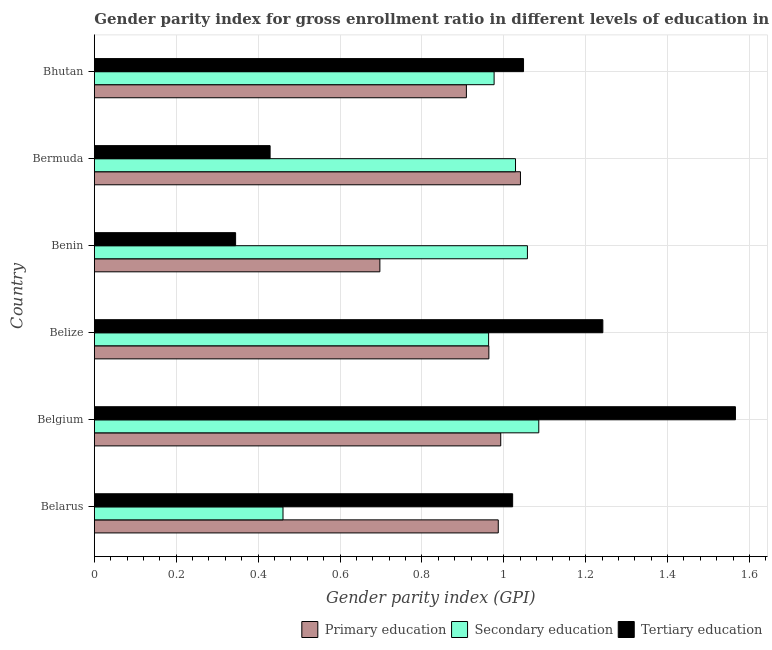How many different coloured bars are there?
Give a very brief answer. 3. Are the number of bars per tick equal to the number of legend labels?
Keep it short and to the point. Yes. How many bars are there on the 5th tick from the top?
Offer a terse response. 3. How many bars are there on the 1st tick from the bottom?
Your response must be concise. 3. What is the label of the 4th group of bars from the top?
Make the answer very short. Belize. What is the gender parity index in secondary education in Bermuda?
Offer a terse response. 1.03. Across all countries, what is the maximum gender parity index in primary education?
Your response must be concise. 1.04. Across all countries, what is the minimum gender parity index in secondary education?
Make the answer very short. 0.46. In which country was the gender parity index in primary education maximum?
Provide a short and direct response. Bermuda. In which country was the gender parity index in tertiary education minimum?
Your response must be concise. Benin. What is the total gender parity index in tertiary education in the graph?
Offer a very short reply. 5.65. What is the difference between the gender parity index in tertiary education in Belize and that in Bhutan?
Your response must be concise. 0.19. What is the difference between the gender parity index in secondary education in Bermuda and the gender parity index in tertiary education in Benin?
Offer a terse response. 0.68. What is the average gender parity index in primary education per country?
Give a very brief answer. 0.93. What is the difference between the gender parity index in tertiary education and gender parity index in secondary education in Belgium?
Your answer should be compact. 0.48. In how many countries, is the gender parity index in tertiary education greater than 1.56 ?
Provide a succinct answer. 1. What is the ratio of the gender parity index in primary education in Bermuda to that in Bhutan?
Keep it short and to the point. 1.15. Is the gender parity index in tertiary education in Belize less than that in Bhutan?
Provide a short and direct response. No. Is the difference between the gender parity index in secondary education in Belarus and Bhutan greater than the difference between the gender parity index in tertiary education in Belarus and Bhutan?
Your answer should be compact. No. What is the difference between the highest and the second highest gender parity index in tertiary education?
Ensure brevity in your answer.  0.32. What is the difference between the highest and the lowest gender parity index in primary education?
Your answer should be very brief. 0.34. What does the 1st bar from the top in Bhutan represents?
Your answer should be compact. Tertiary education. What does the 2nd bar from the bottom in Belarus represents?
Give a very brief answer. Secondary education. Is it the case that in every country, the sum of the gender parity index in primary education and gender parity index in secondary education is greater than the gender parity index in tertiary education?
Provide a succinct answer. Yes. What is the difference between two consecutive major ticks on the X-axis?
Provide a short and direct response. 0.2. Does the graph contain any zero values?
Make the answer very short. No. Does the graph contain grids?
Give a very brief answer. Yes. How are the legend labels stacked?
Your response must be concise. Horizontal. What is the title of the graph?
Your answer should be compact. Gender parity index for gross enrollment ratio in different levels of education in 2002. What is the label or title of the X-axis?
Offer a terse response. Gender parity index (GPI). What is the Gender parity index (GPI) of Primary education in Belarus?
Provide a succinct answer. 0.99. What is the Gender parity index (GPI) of Secondary education in Belarus?
Offer a very short reply. 0.46. What is the Gender parity index (GPI) in Tertiary education in Belarus?
Provide a short and direct response. 1.02. What is the Gender parity index (GPI) in Primary education in Belgium?
Your response must be concise. 0.99. What is the Gender parity index (GPI) of Secondary education in Belgium?
Ensure brevity in your answer.  1.09. What is the Gender parity index (GPI) in Tertiary education in Belgium?
Make the answer very short. 1.57. What is the Gender parity index (GPI) in Primary education in Belize?
Offer a terse response. 0.96. What is the Gender parity index (GPI) of Secondary education in Belize?
Offer a very short reply. 0.96. What is the Gender parity index (GPI) of Tertiary education in Belize?
Keep it short and to the point. 1.24. What is the Gender parity index (GPI) in Primary education in Benin?
Provide a short and direct response. 0.7. What is the Gender parity index (GPI) of Secondary education in Benin?
Offer a terse response. 1.06. What is the Gender parity index (GPI) in Tertiary education in Benin?
Give a very brief answer. 0.35. What is the Gender parity index (GPI) in Primary education in Bermuda?
Provide a succinct answer. 1.04. What is the Gender parity index (GPI) of Secondary education in Bermuda?
Offer a very short reply. 1.03. What is the Gender parity index (GPI) of Tertiary education in Bermuda?
Provide a succinct answer. 0.43. What is the Gender parity index (GPI) of Primary education in Bhutan?
Your response must be concise. 0.91. What is the Gender parity index (GPI) in Secondary education in Bhutan?
Ensure brevity in your answer.  0.98. What is the Gender parity index (GPI) in Tertiary education in Bhutan?
Your answer should be very brief. 1.05. Across all countries, what is the maximum Gender parity index (GPI) of Primary education?
Your answer should be very brief. 1.04. Across all countries, what is the maximum Gender parity index (GPI) of Secondary education?
Provide a succinct answer. 1.09. Across all countries, what is the maximum Gender parity index (GPI) in Tertiary education?
Offer a very short reply. 1.57. Across all countries, what is the minimum Gender parity index (GPI) in Primary education?
Your response must be concise. 0.7. Across all countries, what is the minimum Gender parity index (GPI) in Secondary education?
Provide a succinct answer. 0.46. Across all countries, what is the minimum Gender parity index (GPI) of Tertiary education?
Offer a terse response. 0.35. What is the total Gender parity index (GPI) of Primary education in the graph?
Provide a short and direct response. 5.59. What is the total Gender parity index (GPI) of Secondary education in the graph?
Offer a very short reply. 5.57. What is the total Gender parity index (GPI) of Tertiary education in the graph?
Offer a very short reply. 5.65. What is the difference between the Gender parity index (GPI) of Primary education in Belarus and that in Belgium?
Give a very brief answer. -0.01. What is the difference between the Gender parity index (GPI) of Secondary education in Belarus and that in Belgium?
Your answer should be compact. -0.62. What is the difference between the Gender parity index (GPI) in Tertiary education in Belarus and that in Belgium?
Your answer should be very brief. -0.54. What is the difference between the Gender parity index (GPI) in Primary education in Belarus and that in Belize?
Provide a succinct answer. 0.02. What is the difference between the Gender parity index (GPI) in Secondary education in Belarus and that in Belize?
Your answer should be very brief. -0.5. What is the difference between the Gender parity index (GPI) of Tertiary education in Belarus and that in Belize?
Provide a succinct answer. -0.22. What is the difference between the Gender parity index (GPI) in Primary education in Belarus and that in Benin?
Your answer should be compact. 0.29. What is the difference between the Gender parity index (GPI) of Secondary education in Belarus and that in Benin?
Offer a very short reply. -0.6. What is the difference between the Gender parity index (GPI) of Tertiary education in Belarus and that in Benin?
Your response must be concise. 0.68. What is the difference between the Gender parity index (GPI) in Primary education in Belarus and that in Bermuda?
Ensure brevity in your answer.  -0.05. What is the difference between the Gender parity index (GPI) of Secondary education in Belarus and that in Bermuda?
Your answer should be compact. -0.57. What is the difference between the Gender parity index (GPI) in Tertiary education in Belarus and that in Bermuda?
Offer a terse response. 0.59. What is the difference between the Gender parity index (GPI) in Primary education in Belarus and that in Bhutan?
Keep it short and to the point. 0.08. What is the difference between the Gender parity index (GPI) of Secondary education in Belarus and that in Bhutan?
Your answer should be compact. -0.52. What is the difference between the Gender parity index (GPI) in Tertiary education in Belarus and that in Bhutan?
Provide a short and direct response. -0.03. What is the difference between the Gender parity index (GPI) in Primary education in Belgium and that in Belize?
Give a very brief answer. 0.03. What is the difference between the Gender parity index (GPI) in Secondary education in Belgium and that in Belize?
Make the answer very short. 0.12. What is the difference between the Gender parity index (GPI) in Tertiary education in Belgium and that in Belize?
Your response must be concise. 0.32. What is the difference between the Gender parity index (GPI) in Primary education in Belgium and that in Benin?
Keep it short and to the point. 0.3. What is the difference between the Gender parity index (GPI) in Secondary education in Belgium and that in Benin?
Give a very brief answer. 0.03. What is the difference between the Gender parity index (GPI) of Tertiary education in Belgium and that in Benin?
Make the answer very short. 1.22. What is the difference between the Gender parity index (GPI) in Primary education in Belgium and that in Bermuda?
Your answer should be compact. -0.05. What is the difference between the Gender parity index (GPI) of Secondary education in Belgium and that in Bermuda?
Offer a very short reply. 0.06. What is the difference between the Gender parity index (GPI) of Tertiary education in Belgium and that in Bermuda?
Provide a short and direct response. 1.14. What is the difference between the Gender parity index (GPI) of Primary education in Belgium and that in Bhutan?
Provide a succinct answer. 0.08. What is the difference between the Gender parity index (GPI) of Secondary education in Belgium and that in Bhutan?
Your answer should be very brief. 0.11. What is the difference between the Gender parity index (GPI) in Tertiary education in Belgium and that in Bhutan?
Your response must be concise. 0.52. What is the difference between the Gender parity index (GPI) in Primary education in Belize and that in Benin?
Offer a very short reply. 0.27. What is the difference between the Gender parity index (GPI) of Secondary education in Belize and that in Benin?
Your response must be concise. -0.09. What is the difference between the Gender parity index (GPI) in Tertiary education in Belize and that in Benin?
Ensure brevity in your answer.  0.9. What is the difference between the Gender parity index (GPI) in Primary education in Belize and that in Bermuda?
Offer a terse response. -0.08. What is the difference between the Gender parity index (GPI) in Secondary education in Belize and that in Bermuda?
Keep it short and to the point. -0.07. What is the difference between the Gender parity index (GPI) of Tertiary education in Belize and that in Bermuda?
Provide a succinct answer. 0.81. What is the difference between the Gender parity index (GPI) of Primary education in Belize and that in Bhutan?
Provide a succinct answer. 0.05. What is the difference between the Gender parity index (GPI) of Secondary education in Belize and that in Bhutan?
Give a very brief answer. -0.01. What is the difference between the Gender parity index (GPI) of Tertiary education in Belize and that in Bhutan?
Your answer should be compact. 0.19. What is the difference between the Gender parity index (GPI) in Primary education in Benin and that in Bermuda?
Make the answer very short. -0.34. What is the difference between the Gender parity index (GPI) in Secondary education in Benin and that in Bermuda?
Provide a short and direct response. 0.03. What is the difference between the Gender parity index (GPI) in Tertiary education in Benin and that in Bermuda?
Provide a succinct answer. -0.08. What is the difference between the Gender parity index (GPI) in Primary education in Benin and that in Bhutan?
Offer a terse response. -0.21. What is the difference between the Gender parity index (GPI) of Secondary education in Benin and that in Bhutan?
Give a very brief answer. 0.08. What is the difference between the Gender parity index (GPI) of Tertiary education in Benin and that in Bhutan?
Your answer should be very brief. -0.7. What is the difference between the Gender parity index (GPI) in Primary education in Bermuda and that in Bhutan?
Ensure brevity in your answer.  0.13. What is the difference between the Gender parity index (GPI) in Secondary education in Bermuda and that in Bhutan?
Provide a succinct answer. 0.05. What is the difference between the Gender parity index (GPI) in Tertiary education in Bermuda and that in Bhutan?
Provide a succinct answer. -0.62. What is the difference between the Gender parity index (GPI) of Primary education in Belarus and the Gender parity index (GPI) of Secondary education in Belgium?
Offer a terse response. -0.1. What is the difference between the Gender parity index (GPI) in Primary education in Belarus and the Gender parity index (GPI) in Tertiary education in Belgium?
Provide a succinct answer. -0.58. What is the difference between the Gender parity index (GPI) in Secondary education in Belarus and the Gender parity index (GPI) in Tertiary education in Belgium?
Your response must be concise. -1.1. What is the difference between the Gender parity index (GPI) in Primary education in Belarus and the Gender parity index (GPI) in Secondary education in Belize?
Offer a very short reply. 0.02. What is the difference between the Gender parity index (GPI) in Primary education in Belarus and the Gender parity index (GPI) in Tertiary education in Belize?
Provide a short and direct response. -0.26. What is the difference between the Gender parity index (GPI) in Secondary education in Belarus and the Gender parity index (GPI) in Tertiary education in Belize?
Your response must be concise. -0.78. What is the difference between the Gender parity index (GPI) of Primary education in Belarus and the Gender parity index (GPI) of Secondary education in Benin?
Your answer should be compact. -0.07. What is the difference between the Gender parity index (GPI) in Primary education in Belarus and the Gender parity index (GPI) in Tertiary education in Benin?
Offer a very short reply. 0.64. What is the difference between the Gender parity index (GPI) of Secondary education in Belarus and the Gender parity index (GPI) of Tertiary education in Benin?
Provide a succinct answer. 0.12. What is the difference between the Gender parity index (GPI) of Primary education in Belarus and the Gender parity index (GPI) of Secondary education in Bermuda?
Your answer should be very brief. -0.04. What is the difference between the Gender parity index (GPI) in Primary education in Belarus and the Gender parity index (GPI) in Tertiary education in Bermuda?
Keep it short and to the point. 0.56. What is the difference between the Gender parity index (GPI) in Secondary education in Belarus and the Gender parity index (GPI) in Tertiary education in Bermuda?
Your response must be concise. 0.03. What is the difference between the Gender parity index (GPI) in Primary education in Belarus and the Gender parity index (GPI) in Secondary education in Bhutan?
Keep it short and to the point. 0.01. What is the difference between the Gender parity index (GPI) of Primary education in Belarus and the Gender parity index (GPI) of Tertiary education in Bhutan?
Give a very brief answer. -0.06. What is the difference between the Gender parity index (GPI) in Secondary education in Belarus and the Gender parity index (GPI) in Tertiary education in Bhutan?
Give a very brief answer. -0.59. What is the difference between the Gender parity index (GPI) in Primary education in Belgium and the Gender parity index (GPI) in Secondary education in Belize?
Ensure brevity in your answer.  0.03. What is the difference between the Gender parity index (GPI) of Primary education in Belgium and the Gender parity index (GPI) of Tertiary education in Belize?
Ensure brevity in your answer.  -0.25. What is the difference between the Gender parity index (GPI) in Secondary education in Belgium and the Gender parity index (GPI) in Tertiary education in Belize?
Provide a short and direct response. -0.16. What is the difference between the Gender parity index (GPI) in Primary education in Belgium and the Gender parity index (GPI) in Secondary education in Benin?
Offer a terse response. -0.07. What is the difference between the Gender parity index (GPI) of Primary education in Belgium and the Gender parity index (GPI) of Tertiary education in Benin?
Give a very brief answer. 0.65. What is the difference between the Gender parity index (GPI) in Secondary education in Belgium and the Gender parity index (GPI) in Tertiary education in Benin?
Give a very brief answer. 0.74. What is the difference between the Gender parity index (GPI) in Primary education in Belgium and the Gender parity index (GPI) in Secondary education in Bermuda?
Provide a short and direct response. -0.04. What is the difference between the Gender parity index (GPI) of Primary education in Belgium and the Gender parity index (GPI) of Tertiary education in Bermuda?
Ensure brevity in your answer.  0.56. What is the difference between the Gender parity index (GPI) in Secondary education in Belgium and the Gender parity index (GPI) in Tertiary education in Bermuda?
Make the answer very short. 0.66. What is the difference between the Gender parity index (GPI) of Primary education in Belgium and the Gender parity index (GPI) of Secondary education in Bhutan?
Offer a very short reply. 0.02. What is the difference between the Gender parity index (GPI) of Primary education in Belgium and the Gender parity index (GPI) of Tertiary education in Bhutan?
Give a very brief answer. -0.06. What is the difference between the Gender parity index (GPI) in Secondary education in Belgium and the Gender parity index (GPI) in Tertiary education in Bhutan?
Offer a very short reply. 0.04. What is the difference between the Gender parity index (GPI) in Primary education in Belize and the Gender parity index (GPI) in Secondary education in Benin?
Your answer should be compact. -0.09. What is the difference between the Gender parity index (GPI) of Primary education in Belize and the Gender parity index (GPI) of Tertiary education in Benin?
Give a very brief answer. 0.62. What is the difference between the Gender parity index (GPI) of Secondary education in Belize and the Gender parity index (GPI) of Tertiary education in Benin?
Your answer should be very brief. 0.62. What is the difference between the Gender parity index (GPI) in Primary education in Belize and the Gender parity index (GPI) in Secondary education in Bermuda?
Offer a terse response. -0.07. What is the difference between the Gender parity index (GPI) in Primary education in Belize and the Gender parity index (GPI) in Tertiary education in Bermuda?
Keep it short and to the point. 0.53. What is the difference between the Gender parity index (GPI) in Secondary education in Belize and the Gender parity index (GPI) in Tertiary education in Bermuda?
Offer a very short reply. 0.53. What is the difference between the Gender parity index (GPI) of Primary education in Belize and the Gender parity index (GPI) of Secondary education in Bhutan?
Your answer should be compact. -0.01. What is the difference between the Gender parity index (GPI) in Primary education in Belize and the Gender parity index (GPI) in Tertiary education in Bhutan?
Make the answer very short. -0.08. What is the difference between the Gender parity index (GPI) in Secondary education in Belize and the Gender parity index (GPI) in Tertiary education in Bhutan?
Provide a short and direct response. -0.09. What is the difference between the Gender parity index (GPI) of Primary education in Benin and the Gender parity index (GPI) of Secondary education in Bermuda?
Offer a very short reply. -0.33. What is the difference between the Gender parity index (GPI) in Primary education in Benin and the Gender parity index (GPI) in Tertiary education in Bermuda?
Your answer should be very brief. 0.27. What is the difference between the Gender parity index (GPI) in Secondary education in Benin and the Gender parity index (GPI) in Tertiary education in Bermuda?
Your response must be concise. 0.63. What is the difference between the Gender parity index (GPI) of Primary education in Benin and the Gender parity index (GPI) of Secondary education in Bhutan?
Provide a short and direct response. -0.28. What is the difference between the Gender parity index (GPI) in Primary education in Benin and the Gender parity index (GPI) in Tertiary education in Bhutan?
Keep it short and to the point. -0.35. What is the difference between the Gender parity index (GPI) of Secondary education in Benin and the Gender parity index (GPI) of Tertiary education in Bhutan?
Your answer should be compact. 0.01. What is the difference between the Gender parity index (GPI) in Primary education in Bermuda and the Gender parity index (GPI) in Secondary education in Bhutan?
Make the answer very short. 0.06. What is the difference between the Gender parity index (GPI) of Primary education in Bermuda and the Gender parity index (GPI) of Tertiary education in Bhutan?
Provide a short and direct response. -0.01. What is the difference between the Gender parity index (GPI) in Secondary education in Bermuda and the Gender parity index (GPI) in Tertiary education in Bhutan?
Offer a very short reply. -0.02. What is the average Gender parity index (GPI) in Primary education per country?
Offer a very short reply. 0.93. What is the average Gender parity index (GPI) of Secondary education per country?
Ensure brevity in your answer.  0.93. What is the average Gender parity index (GPI) in Tertiary education per country?
Provide a short and direct response. 0.94. What is the difference between the Gender parity index (GPI) in Primary education and Gender parity index (GPI) in Secondary education in Belarus?
Give a very brief answer. 0.53. What is the difference between the Gender parity index (GPI) in Primary education and Gender parity index (GPI) in Tertiary education in Belarus?
Provide a succinct answer. -0.04. What is the difference between the Gender parity index (GPI) of Secondary education and Gender parity index (GPI) of Tertiary education in Belarus?
Give a very brief answer. -0.56. What is the difference between the Gender parity index (GPI) of Primary education and Gender parity index (GPI) of Secondary education in Belgium?
Offer a terse response. -0.09. What is the difference between the Gender parity index (GPI) of Primary education and Gender parity index (GPI) of Tertiary education in Belgium?
Offer a very short reply. -0.57. What is the difference between the Gender parity index (GPI) in Secondary education and Gender parity index (GPI) in Tertiary education in Belgium?
Offer a very short reply. -0.48. What is the difference between the Gender parity index (GPI) of Primary education and Gender parity index (GPI) of Secondary education in Belize?
Make the answer very short. 0. What is the difference between the Gender parity index (GPI) of Primary education and Gender parity index (GPI) of Tertiary education in Belize?
Offer a terse response. -0.28. What is the difference between the Gender parity index (GPI) of Secondary education and Gender parity index (GPI) of Tertiary education in Belize?
Make the answer very short. -0.28. What is the difference between the Gender parity index (GPI) in Primary education and Gender parity index (GPI) in Secondary education in Benin?
Provide a short and direct response. -0.36. What is the difference between the Gender parity index (GPI) of Primary education and Gender parity index (GPI) of Tertiary education in Benin?
Offer a very short reply. 0.35. What is the difference between the Gender parity index (GPI) of Secondary education and Gender parity index (GPI) of Tertiary education in Benin?
Keep it short and to the point. 0.71. What is the difference between the Gender parity index (GPI) in Primary education and Gender parity index (GPI) in Secondary education in Bermuda?
Ensure brevity in your answer.  0.01. What is the difference between the Gender parity index (GPI) of Primary education and Gender parity index (GPI) of Tertiary education in Bermuda?
Provide a succinct answer. 0.61. What is the difference between the Gender parity index (GPI) in Secondary education and Gender parity index (GPI) in Tertiary education in Bermuda?
Offer a terse response. 0.6. What is the difference between the Gender parity index (GPI) of Primary education and Gender parity index (GPI) of Secondary education in Bhutan?
Provide a succinct answer. -0.07. What is the difference between the Gender parity index (GPI) in Primary education and Gender parity index (GPI) in Tertiary education in Bhutan?
Offer a terse response. -0.14. What is the difference between the Gender parity index (GPI) in Secondary education and Gender parity index (GPI) in Tertiary education in Bhutan?
Provide a short and direct response. -0.07. What is the ratio of the Gender parity index (GPI) in Primary education in Belarus to that in Belgium?
Your response must be concise. 0.99. What is the ratio of the Gender parity index (GPI) in Secondary education in Belarus to that in Belgium?
Keep it short and to the point. 0.42. What is the ratio of the Gender parity index (GPI) of Tertiary education in Belarus to that in Belgium?
Give a very brief answer. 0.65. What is the ratio of the Gender parity index (GPI) of Primary education in Belarus to that in Belize?
Give a very brief answer. 1.02. What is the ratio of the Gender parity index (GPI) in Secondary education in Belarus to that in Belize?
Provide a short and direct response. 0.48. What is the ratio of the Gender parity index (GPI) in Tertiary education in Belarus to that in Belize?
Ensure brevity in your answer.  0.82. What is the ratio of the Gender parity index (GPI) in Primary education in Belarus to that in Benin?
Your answer should be very brief. 1.41. What is the ratio of the Gender parity index (GPI) of Secondary education in Belarus to that in Benin?
Provide a short and direct response. 0.44. What is the ratio of the Gender parity index (GPI) of Tertiary education in Belarus to that in Benin?
Ensure brevity in your answer.  2.96. What is the ratio of the Gender parity index (GPI) in Primary education in Belarus to that in Bermuda?
Ensure brevity in your answer.  0.95. What is the ratio of the Gender parity index (GPI) of Secondary education in Belarus to that in Bermuda?
Your response must be concise. 0.45. What is the ratio of the Gender parity index (GPI) in Tertiary education in Belarus to that in Bermuda?
Offer a very short reply. 2.38. What is the ratio of the Gender parity index (GPI) of Primary education in Belarus to that in Bhutan?
Your answer should be very brief. 1.09. What is the ratio of the Gender parity index (GPI) in Secondary education in Belarus to that in Bhutan?
Give a very brief answer. 0.47. What is the ratio of the Gender parity index (GPI) of Tertiary education in Belarus to that in Bhutan?
Provide a short and direct response. 0.97. What is the ratio of the Gender parity index (GPI) of Primary education in Belgium to that in Belize?
Ensure brevity in your answer.  1.03. What is the ratio of the Gender parity index (GPI) of Secondary education in Belgium to that in Belize?
Offer a very short reply. 1.13. What is the ratio of the Gender parity index (GPI) of Tertiary education in Belgium to that in Belize?
Keep it short and to the point. 1.26. What is the ratio of the Gender parity index (GPI) in Primary education in Belgium to that in Benin?
Ensure brevity in your answer.  1.42. What is the ratio of the Gender parity index (GPI) of Secondary education in Belgium to that in Benin?
Offer a terse response. 1.03. What is the ratio of the Gender parity index (GPI) in Tertiary education in Belgium to that in Benin?
Your answer should be very brief. 4.54. What is the ratio of the Gender parity index (GPI) in Primary education in Belgium to that in Bermuda?
Offer a terse response. 0.95. What is the ratio of the Gender parity index (GPI) in Secondary education in Belgium to that in Bermuda?
Give a very brief answer. 1.06. What is the ratio of the Gender parity index (GPI) in Tertiary education in Belgium to that in Bermuda?
Your answer should be very brief. 3.65. What is the ratio of the Gender parity index (GPI) in Primary education in Belgium to that in Bhutan?
Keep it short and to the point. 1.09. What is the ratio of the Gender parity index (GPI) in Secondary education in Belgium to that in Bhutan?
Make the answer very short. 1.11. What is the ratio of the Gender parity index (GPI) in Tertiary education in Belgium to that in Bhutan?
Make the answer very short. 1.49. What is the ratio of the Gender parity index (GPI) of Primary education in Belize to that in Benin?
Keep it short and to the point. 1.38. What is the ratio of the Gender parity index (GPI) of Secondary education in Belize to that in Benin?
Your answer should be very brief. 0.91. What is the ratio of the Gender parity index (GPI) in Tertiary education in Belize to that in Benin?
Give a very brief answer. 3.6. What is the ratio of the Gender parity index (GPI) of Primary education in Belize to that in Bermuda?
Offer a terse response. 0.93. What is the ratio of the Gender parity index (GPI) in Secondary education in Belize to that in Bermuda?
Keep it short and to the point. 0.94. What is the ratio of the Gender parity index (GPI) of Tertiary education in Belize to that in Bermuda?
Provide a short and direct response. 2.89. What is the ratio of the Gender parity index (GPI) in Primary education in Belize to that in Bhutan?
Keep it short and to the point. 1.06. What is the ratio of the Gender parity index (GPI) of Secondary education in Belize to that in Bhutan?
Keep it short and to the point. 0.99. What is the ratio of the Gender parity index (GPI) of Tertiary education in Belize to that in Bhutan?
Make the answer very short. 1.18. What is the ratio of the Gender parity index (GPI) of Primary education in Benin to that in Bermuda?
Give a very brief answer. 0.67. What is the ratio of the Gender parity index (GPI) of Secondary education in Benin to that in Bermuda?
Ensure brevity in your answer.  1.03. What is the ratio of the Gender parity index (GPI) in Tertiary education in Benin to that in Bermuda?
Your answer should be very brief. 0.8. What is the ratio of the Gender parity index (GPI) of Primary education in Benin to that in Bhutan?
Make the answer very short. 0.77. What is the ratio of the Gender parity index (GPI) of Secondary education in Benin to that in Bhutan?
Offer a terse response. 1.08. What is the ratio of the Gender parity index (GPI) in Tertiary education in Benin to that in Bhutan?
Give a very brief answer. 0.33. What is the ratio of the Gender parity index (GPI) of Primary education in Bermuda to that in Bhutan?
Your answer should be compact. 1.15. What is the ratio of the Gender parity index (GPI) in Secondary education in Bermuda to that in Bhutan?
Offer a terse response. 1.05. What is the ratio of the Gender parity index (GPI) of Tertiary education in Bermuda to that in Bhutan?
Give a very brief answer. 0.41. What is the difference between the highest and the second highest Gender parity index (GPI) in Primary education?
Provide a succinct answer. 0.05. What is the difference between the highest and the second highest Gender parity index (GPI) of Secondary education?
Provide a short and direct response. 0.03. What is the difference between the highest and the second highest Gender parity index (GPI) in Tertiary education?
Offer a terse response. 0.32. What is the difference between the highest and the lowest Gender parity index (GPI) of Primary education?
Provide a succinct answer. 0.34. What is the difference between the highest and the lowest Gender parity index (GPI) in Secondary education?
Your answer should be compact. 0.62. What is the difference between the highest and the lowest Gender parity index (GPI) of Tertiary education?
Keep it short and to the point. 1.22. 